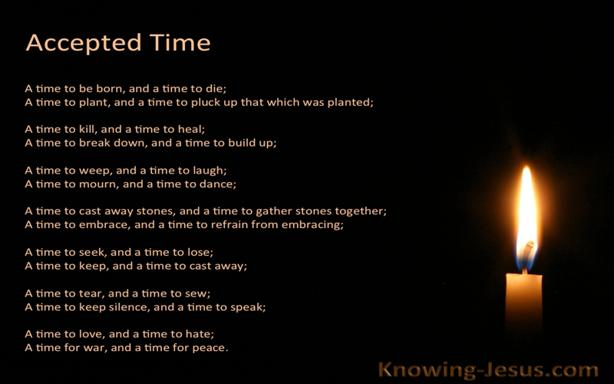Can you explore the significance of the candle shown next to the quote? The candle in the image symbolizes light and guidance amidst darkness, which ties closely to the theme of the quote about times and seasons in life. The flickering candle flame can be seen as a metaphor for life's transient nature and the divine light that guides through periods of uncertainty and change. 